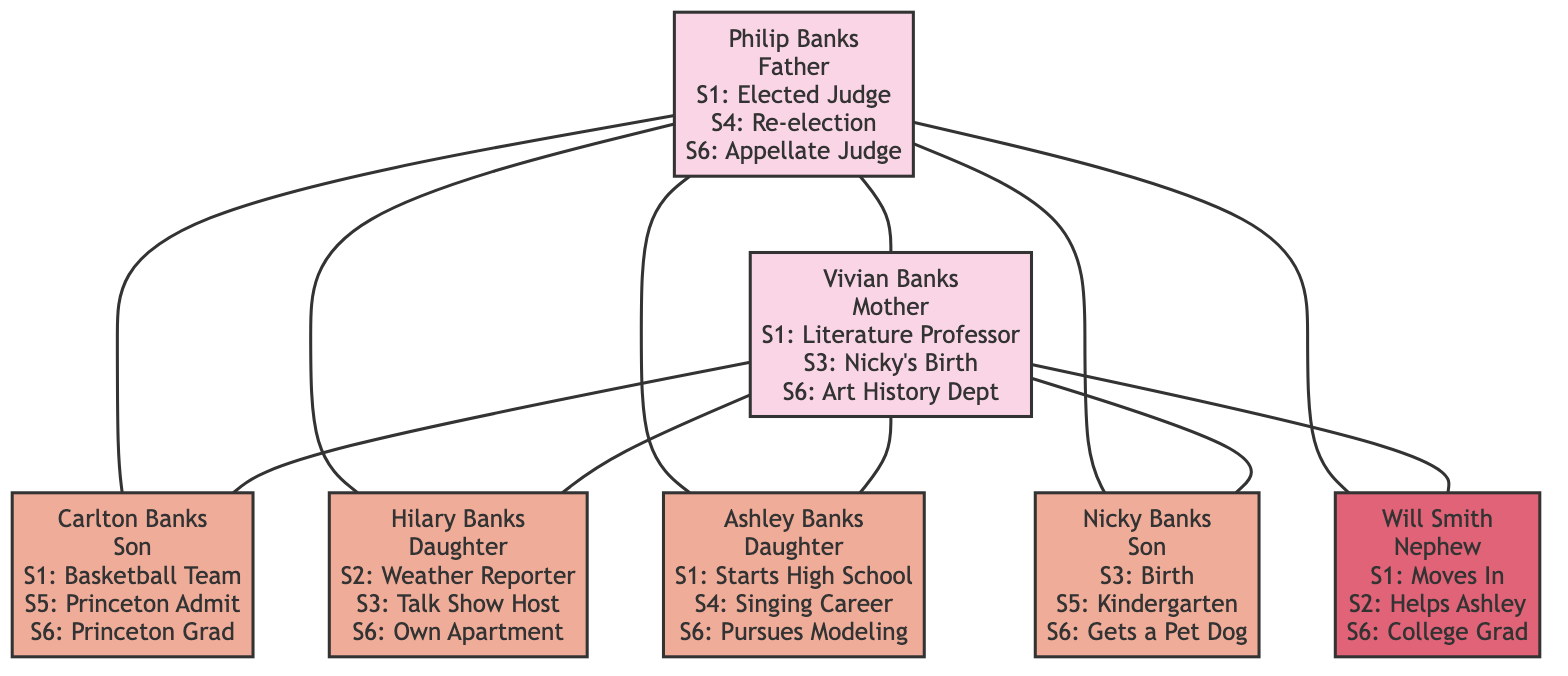What is Philip Banks' role in the family? Philip Banks is labeled as “Father” in the diagram. This can be directly observed from the node corresponding to him.
Answer: Father How many children do Philip and Vivian Banks have? By examining the diagram, we see that Philip and Vivian have four children: Carlton, Hilary, Ashley, and Nicky. Each child is listed as a descendant from the couple.
Answer: Four What significant event happens for Vivian Banks in Season 3? The event listed for Vivian in Season 3 is "Pregnancy and Birth of Nicky Banks". This is explicitly noted in her node in the diagram.
Answer: Pregnancy and Birth of Nicky Banks Which character helps Ashley launch her singing career? Will Smith is noted to help Ashley launch her singing career in Season 2. This is mentioned in Will's node in the diagram.
Answer: Will Smith At what season does Carlton Banks graduate from Princeton University? Carlton Banks’ graduation from Princeton University is listed in Season 6 in his node. This detail helps confirm the timing of this event.
Answer: Season 6 What is the relationship between Will Smith and Philip Banks? Will Smith is identified as the "Nephew" of Philip Banks. This relationship is clearly marked in the diagram, establishing a familial connection.
Answer: Nephew What major life event occurs for Nicky Banks in Season 5? Nicky Banks starts Kindergarten in Season 5, which can be found in his node in the diagram. This indicates a milestone in his development highlighted in the family tree.
Answer: Starts Kindergarten Which character moves into their own apartment in Season 6? Hilary Banks moves into her own Apartment in Season 6, which is specifically noted in her node. This indicates her transition towards independence.
Answer: Hilary Banks Identify the season where Philip Banks runs for re-election. Philip runs for Superior Court Judge re-election in Season 4, as indicated in his node. This is a pivotal moment in his professional life.
Answer: Season 4 